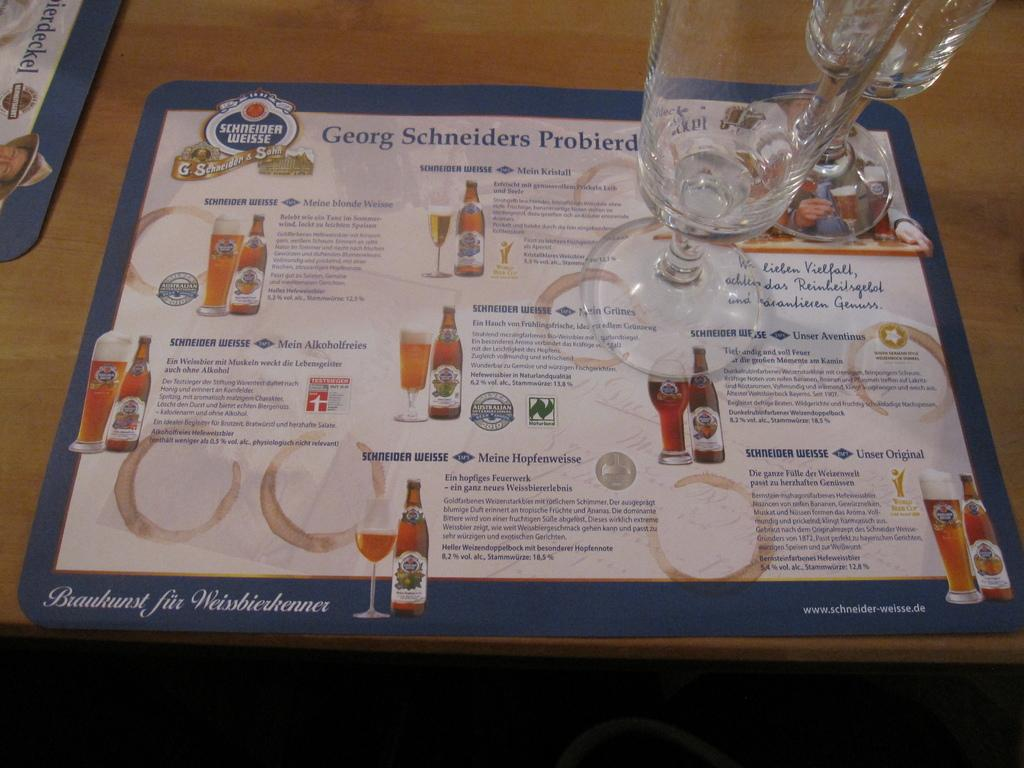<image>
Give a short and clear explanation of the subsequent image. A place mat with information about Schneider Weisse. 